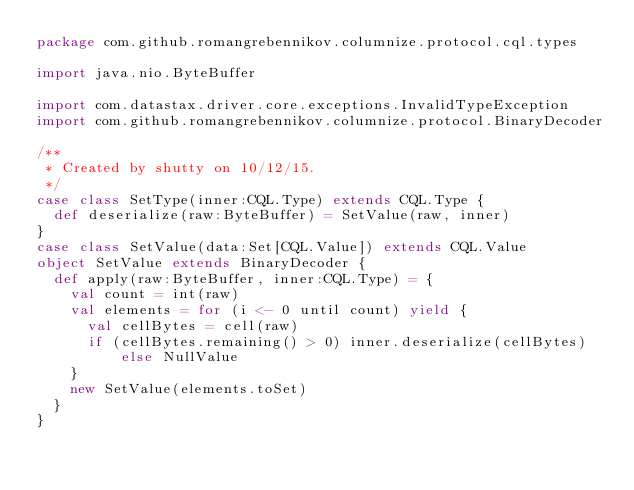<code> <loc_0><loc_0><loc_500><loc_500><_Scala_>package com.github.romangrebennikov.columnize.protocol.cql.types

import java.nio.ByteBuffer

import com.datastax.driver.core.exceptions.InvalidTypeException
import com.github.romangrebennikov.columnize.protocol.BinaryDecoder

/**
 * Created by shutty on 10/12/15.
 */
case class SetType(inner:CQL.Type) extends CQL.Type {
  def deserialize(raw:ByteBuffer) = SetValue(raw, inner)
}
case class SetValue(data:Set[CQL.Value]) extends CQL.Value
object SetValue extends BinaryDecoder {
  def apply(raw:ByteBuffer, inner:CQL.Type) = {
    val count = int(raw)
    val elements = for (i <- 0 until count) yield {
      val cellBytes = cell(raw)
      if (cellBytes.remaining() > 0) inner.deserialize(cellBytes) else NullValue
    }
    new SetValue(elements.toSet)
  }
}
</code> 